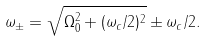Convert formula to latex. <formula><loc_0><loc_0><loc_500><loc_500>\omega _ { \pm } = \sqrt { \Omega _ { 0 } ^ { 2 } + ( \omega _ { c } / 2 ) ^ { 2 } } \pm \omega _ { c } / 2 .</formula> 